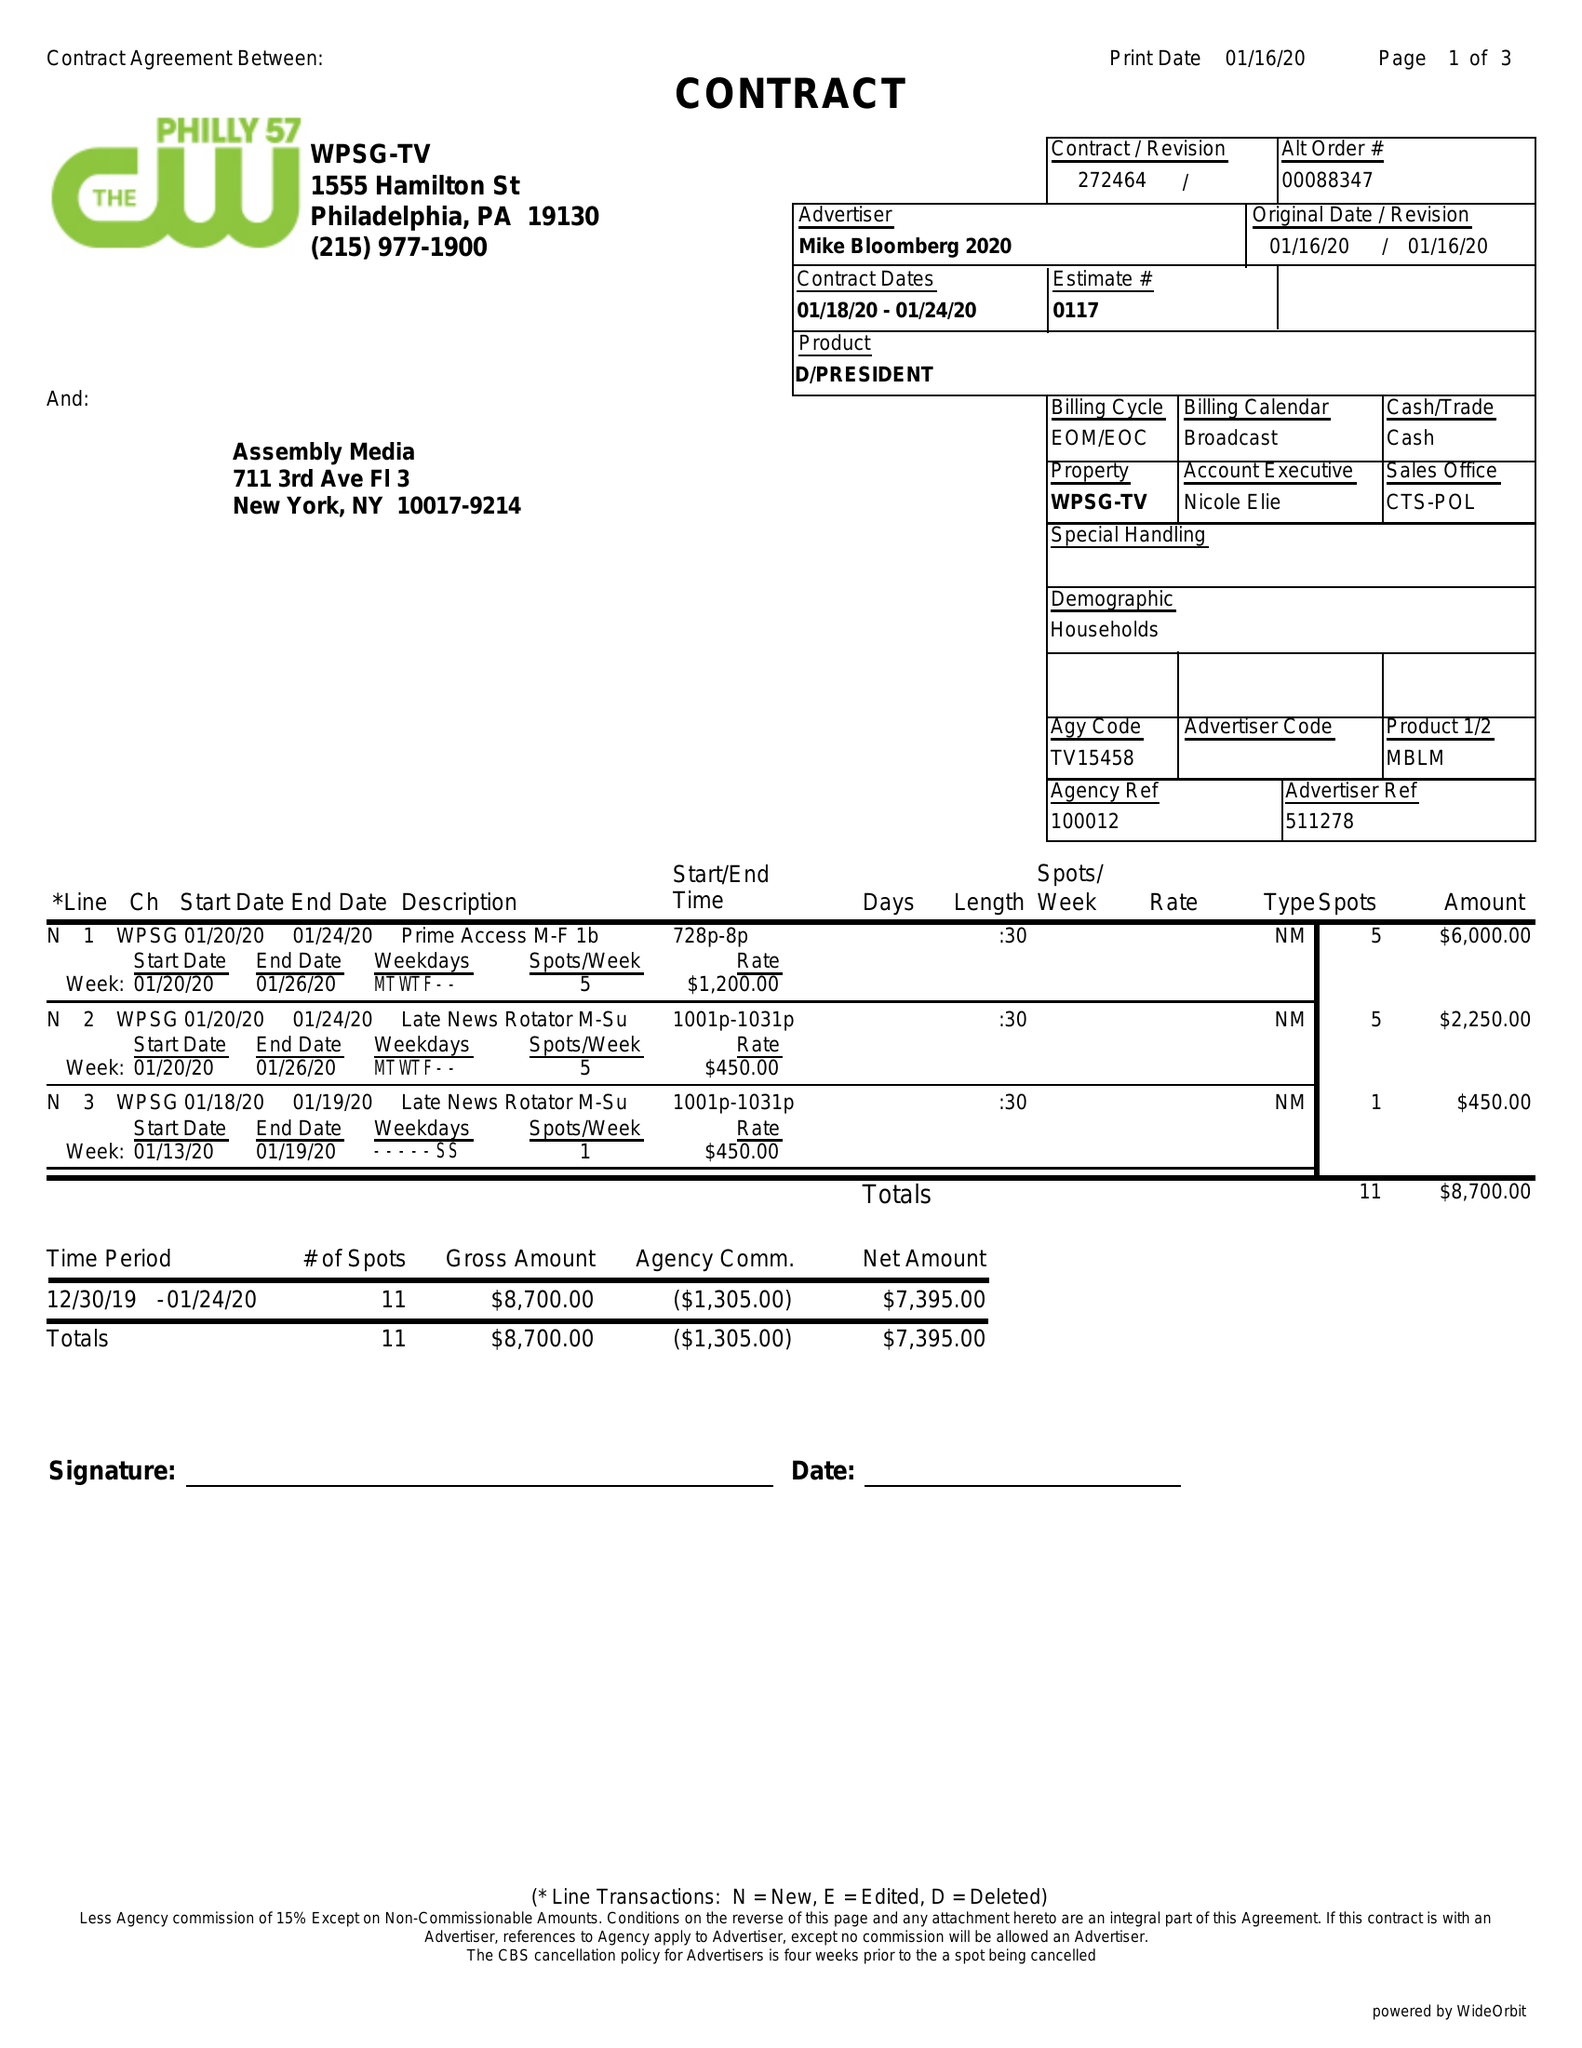What is the value for the flight_to?
Answer the question using a single word or phrase. 01/24/20 